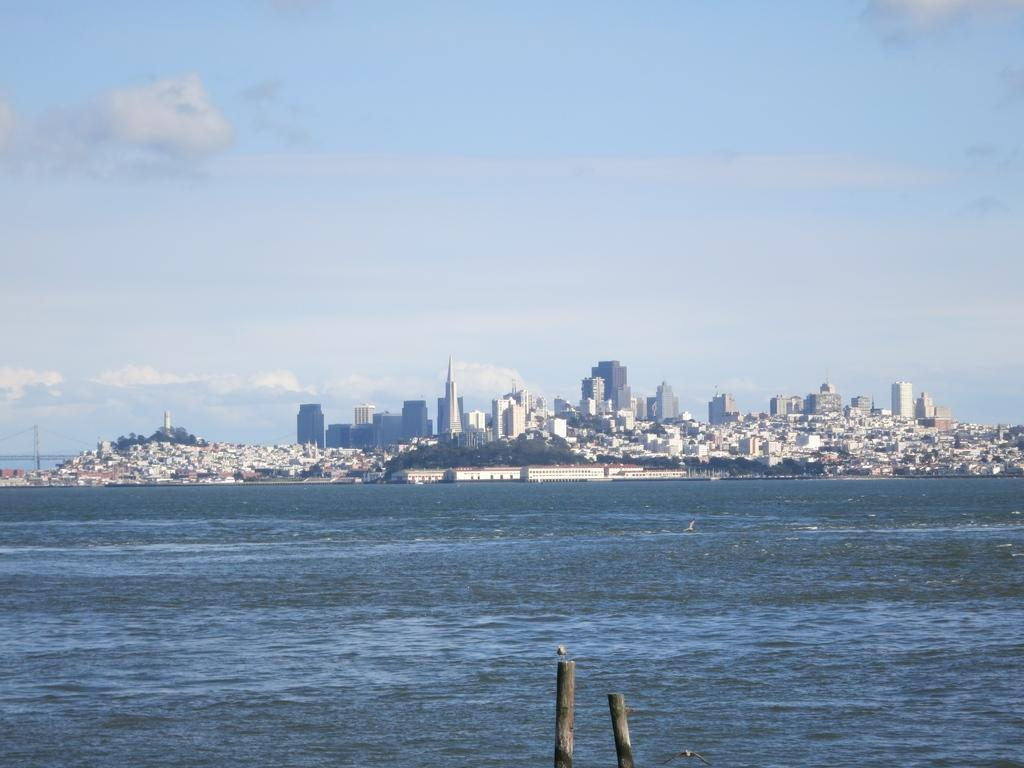What type of water is depicted in the image? The image contains an ocean. What can be seen in the background of the image? There are buildings and trees in the background of the image. How would you describe the sky in the image? The sky is blue and has clouds in it. What type of stocking is hanging from the tree in the image? There is no stocking hanging from the tree in the image; it only contains trees and buildings in the background. 